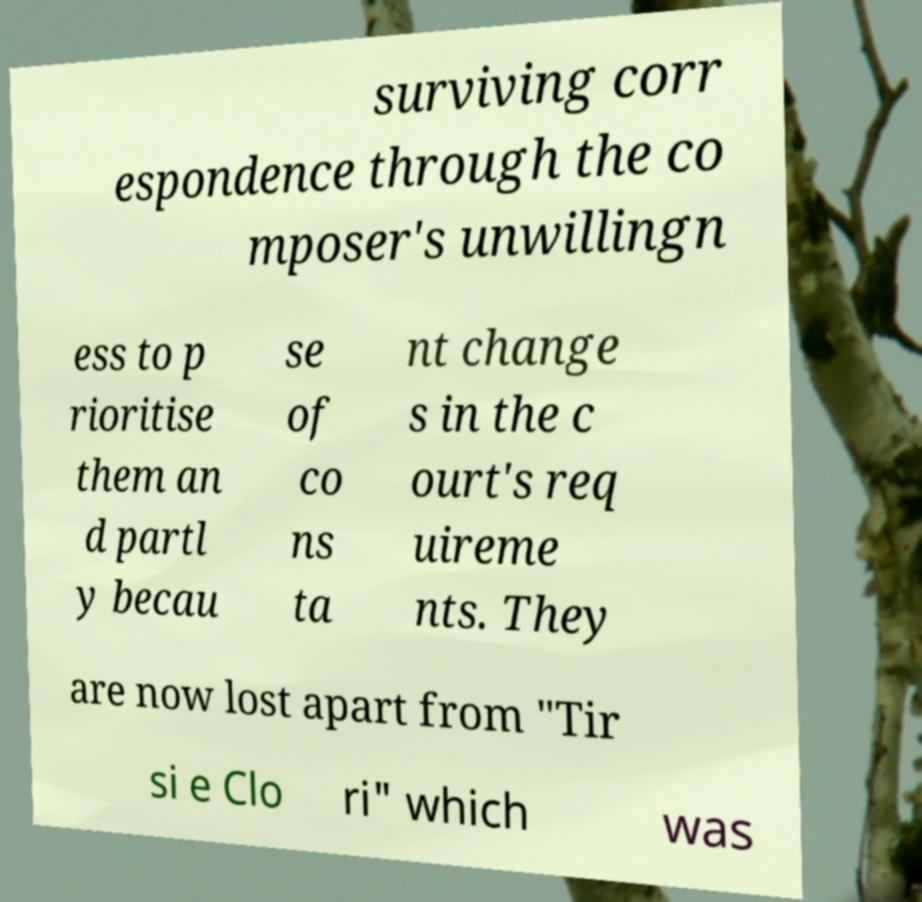Please identify and transcribe the text found in this image. surviving corr espondence through the co mposer's unwillingn ess to p rioritise them an d partl y becau se of co ns ta nt change s in the c ourt's req uireme nts. They are now lost apart from "Tir si e Clo ri" which was 